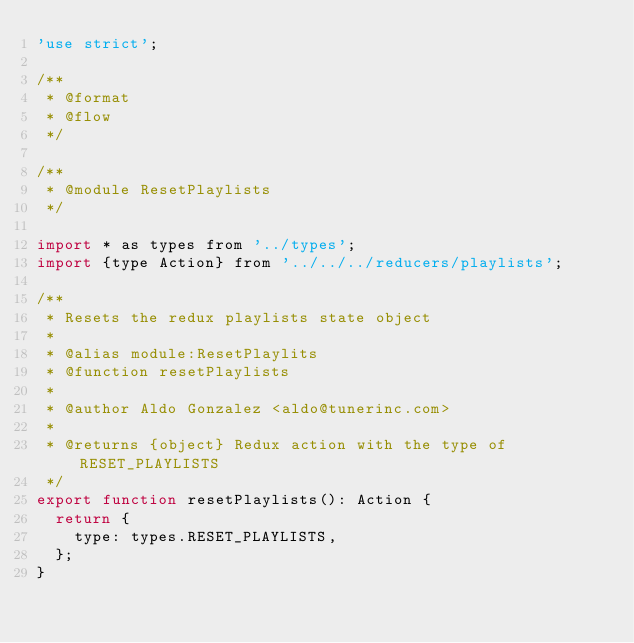Convert code to text. <code><loc_0><loc_0><loc_500><loc_500><_JavaScript_>'use strict';

/**
 * @format
 * @flow
 */

/**
 * @module ResetPlaylists
 */

import * as types from '../types';
import {type Action} from '../../../reducers/playlists';

/**
 * Resets the redux playlists state object
 * 
 * @alias module:ResetPlaylits
 * @function resetPlaylists
 * 
 * @author Aldo Gonzalez <aldo@tunerinc.com>
 * 
 * @returns {object} Redux action with the type of RESET_PLAYLISTS
 */
export function resetPlaylists(): Action {
  return {
    type: types.RESET_PLAYLISTS,
  };
}</code> 